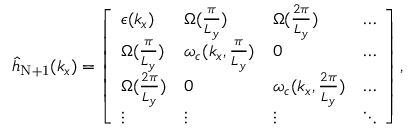Convert formula to latex. <formula><loc_0><loc_0><loc_500><loc_500>\begin{array} { r } { { \hat { h } } _ { N + 1 } ( { k _ { x } } ) = \left [ \begin{array} { l l l l } { \epsilon ( k _ { x } ) } & { { \Omega } ( \frac { \pi } { L _ { y } } ) } & { { \Omega } ( \frac { 2 \pi } { L _ { y } } ) } & { \hdots } \\ { { \Omega } ( \frac { \pi } { L _ { y } } ) } & { \omega _ { c } ( { k _ { x } , \frac { \pi } { L _ { y } } } ) } & { 0 } & { \hdots } \\ { { \Omega } ( \frac { 2 \pi } { L _ { y } } ) } & { 0 } & { \omega _ { c } ( { k _ { x } , \frac { 2 \pi } { L _ { y } } } ) } & { \hdots } \\ { \vdots } & { \vdots } & { \vdots } & { \ddots } \end{array} \right ] , } \end{array}</formula> 